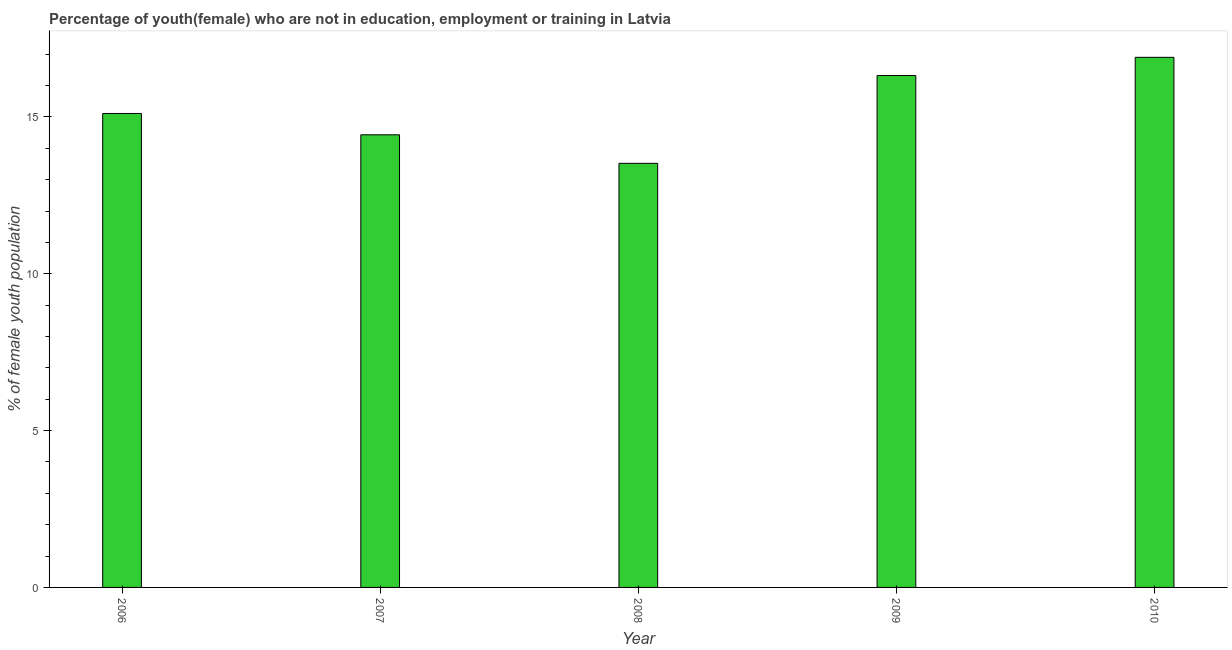Does the graph contain any zero values?
Offer a very short reply. No. What is the title of the graph?
Your answer should be very brief. Percentage of youth(female) who are not in education, employment or training in Latvia. What is the label or title of the X-axis?
Keep it short and to the point. Year. What is the label or title of the Y-axis?
Your answer should be compact. % of female youth population. What is the unemployed female youth population in 2006?
Your response must be concise. 15.11. Across all years, what is the maximum unemployed female youth population?
Make the answer very short. 16.9. Across all years, what is the minimum unemployed female youth population?
Offer a terse response. 13.52. In which year was the unemployed female youth population maximum?
Ensure brevity in your answer.  2010. What is the sum of the unemployed female youth population?
Keep it short and to the point. 76.28. What is the difference between the unemployed female youth population in 2007 and 2008?
Offer a terse response. 0.91. What is the average unemployed female youth population per year?
Your answer should be very brief. 15.26. What is the median unemployed female youth population?
Offer a very short reply. 15.11. In how many years, is the unemployed female youth population greater than 8 %?
Make the answer very short. 5. What is the ratio of the unemployed female youth population in 2006 to that in 2008?
Ensure brevity in your answer.  1.12. What is the difference between the highest and the second highest unemployed female youth population?
Your answer should be compact. 0.58. What is the difference between the highest and the lowest unemployed female youth population?
Keep it short and to the point. 3.38. How many years are there in the graph?
Your answer should be very brief. 5. What is the difference between two consecutive major ticks on the Y-axis?
Your response must be concise. 5. Are the values on the major ticks of Y-axis written in scientific E-notation?
Keep it short and to the point. No. What is the % of female youth population of 2006?
Your response must be concise. 15.11. What is the % of female youth population in 2007?
Offer a terse response. 14.43. What is the % of female youth population in 2008?
Ensure brevity in your answer.  13.52. What is the % of female youth population of 2009?
Your answer should be compact. 16.32. What is the % of female youth population in 2010?
Offer a very short reply. 16.9. What is the difference between the % of female youth population in 2006 and 2007?
Offer a very short reply. 0.68. What is the difference between the % of female youth population in 2006 and 2008?
Offer a very short reply. 1.59. What is the difference between the % of female youth population in 2006 and 2009?
Offer a terse response. -1.21. What is the difference between the % of female youth population in 2006 and 2010?
Provide a succinct answer. -1.79. What is the difference between the % of female youth population in 2007 and 2008?
Offer a very short reply. 0.91. What is the difference between the % of female youth population in 2007 and 2009?
Provide a short and direct response. -1.89. What is the difference between the % of female youth population in 2007 and 2010?
Your answer should be compact. -2.47. What is the difference between the % of female youth population in 2008 and 2010?
Your response must be concise. -3.38. What is the difference between the % of female youth population in 2009 and 2010?
Keep it short and to the point. -0.58. What is the ratio of the % of female youth population in 2006 to that in 2007?
Make the answer very short. 1.05. What is the ratio of the % of female youth population in 2006 to that in 2008?
Provide a short and direct response. 1.12. What is the ratio of the % of female youth population in 2006 to that in 2009?
Provide a succinct answer. 0.93. What is the ratio of the % of female youth population in 2006 to that in 2010?
Make the answer very short. 0.89. What is the ratio of the % of female youth population in 2007 to that in 2008?
Your answer should be very brief. 1.07. What is the ratio of the % of female youth population in 2007 to that in 2009?
Give a very brief answer. 0.88. What is the ratio of the % of female youth population in 2007 to that in 2010?
Your answer should be compact. 0.85. What is the ratio of the % of female youth population in 2008 to that in 2009?
Your answer should be very brief. 0.83. What is the ratio of the % of female youth population in 2008 to that in 2010?
Your answer should be very brief. 0.8. 